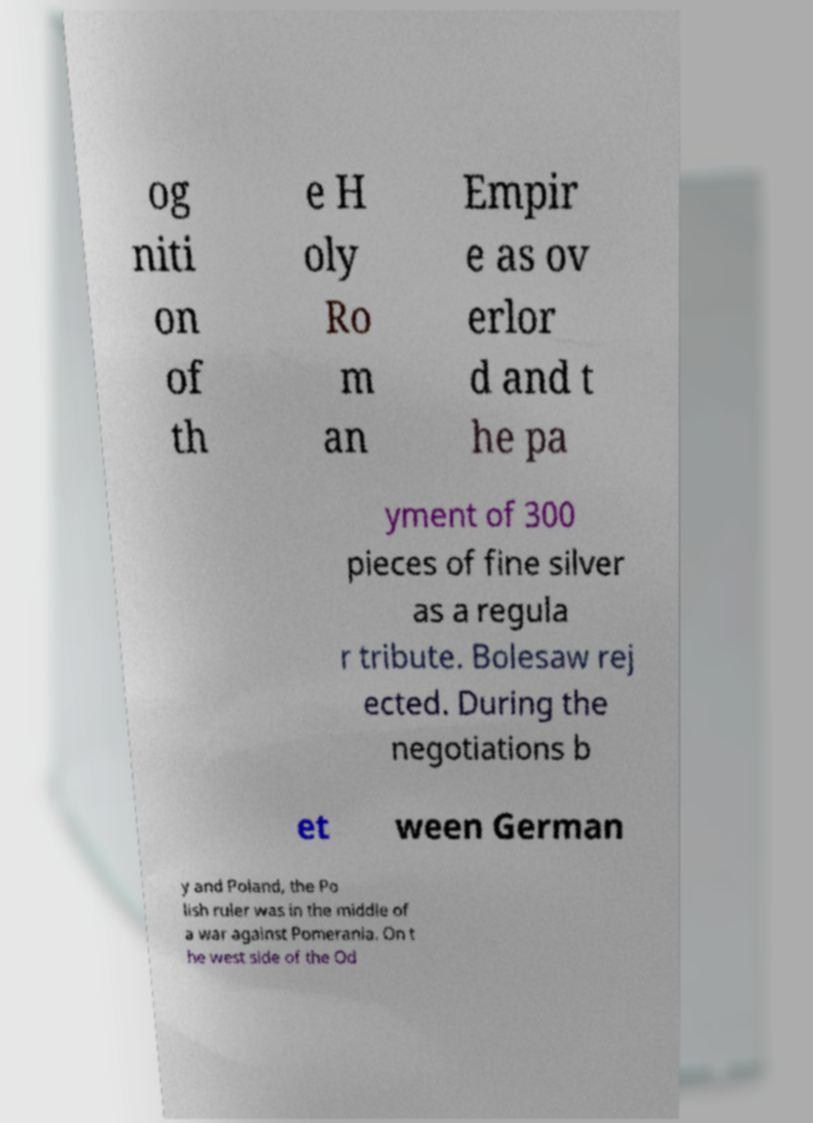For documentation purposes, I need the text within this image transcribed. Could you provide that? og niti on of th e H oly Ro m an Empir e as ov erlor d and t he pa yment of 300 pieces of fine silver as a regula r tribute. Bolesaw rej ected. During the negotiations b et ween German y and Poland, the Po lish ruler was in the middle of a war against Pomerania. On t he west side of the Od 